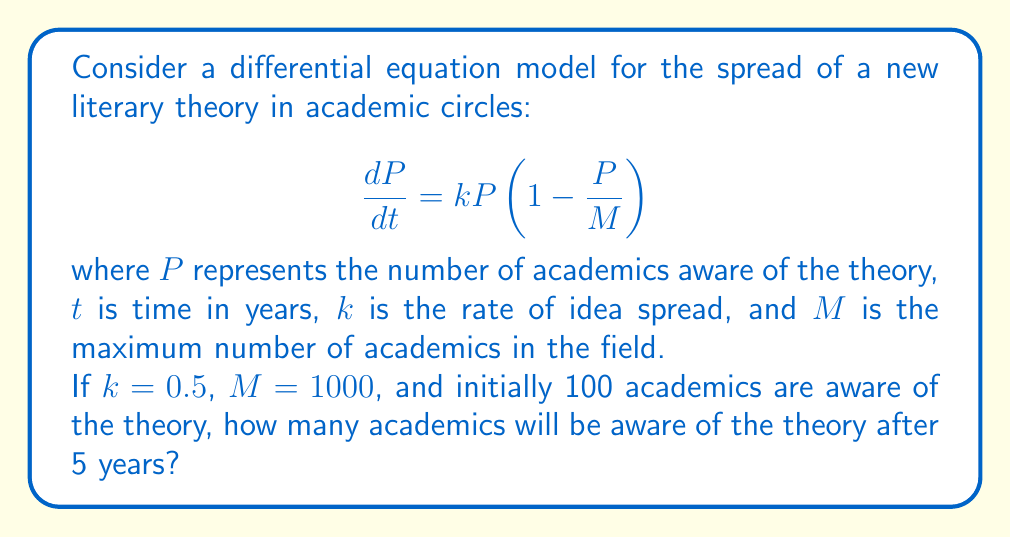What is the answer to this math problem? 1) We start with the logistic differential equation:
   $$\frac{dP}{dt} = kP(1-\frac{P}{M})$$

2) The solution to this equation is:
   $$P(t) = \frac{M}{1 + (\frac{M}{P_0} - 1)e^{-kt}}$$
   where $P_0$ is the initial population.

3) We're given:
   $k = 0.5$, $M = 1000$, $P_0 = 100$, and we want to find $P(5)$

4) Substituting these values into our solution:
   $$P(5) = \frac{1000}{1 + (\frac{1000}{100} - 1)e^{-0.5(5)}}$$

5) Simplify:
   $$P(5) = \frac{1000}{1 + 9e^{-2.5}}$$

6) Calculate:
   $$P(5) = \frac{1000}{1 + 9(0.0821)} \approx 930.23$$

7) Since we're dealing with whole academics, we round down to the nearest integer.
Answer: 930 academics 